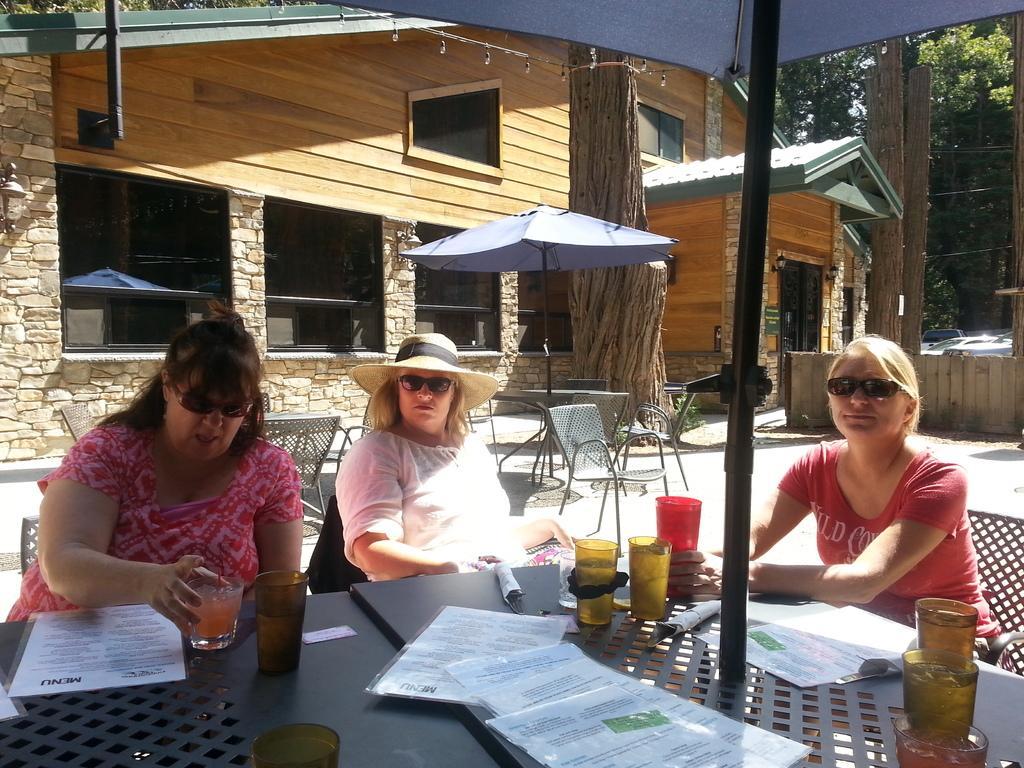Describe this image in one or two sentences. There are three women, sitting in the chairs in front of a table. On the table, there are some papers, glasses here. All of them were wearing spectacles. In the background there are some tables and chairs. We can observe a building and a tree here. 